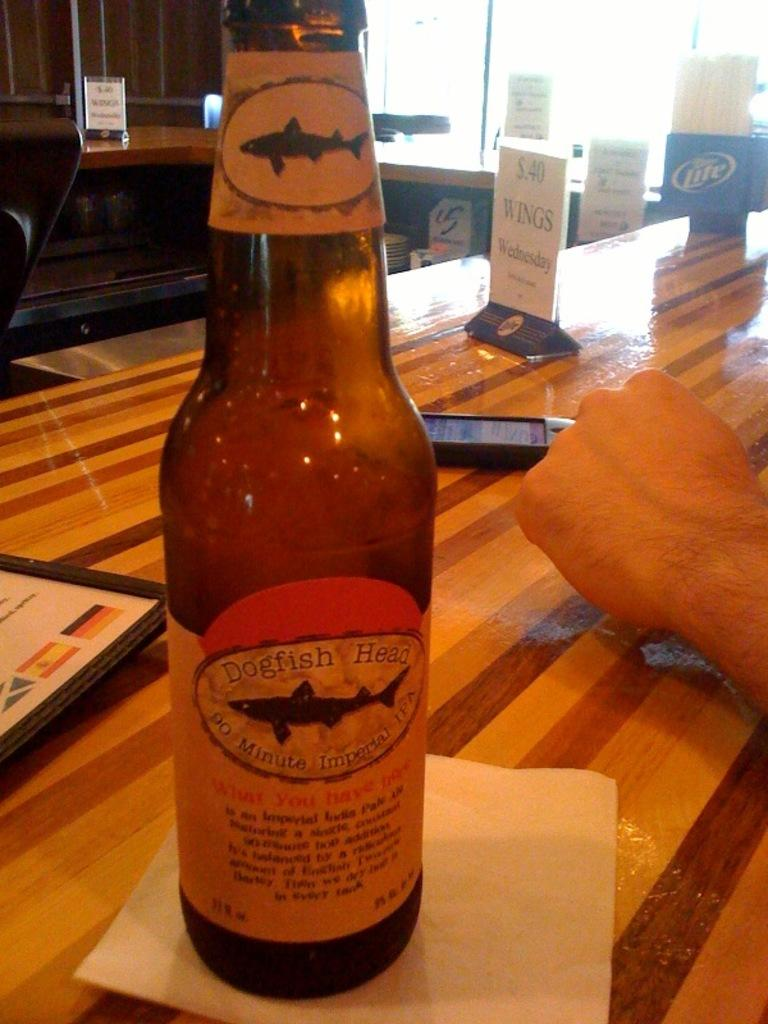Provide a one-sentence caption for the provided image. A wood table with a bottle of beer titled Dogfish Head. 